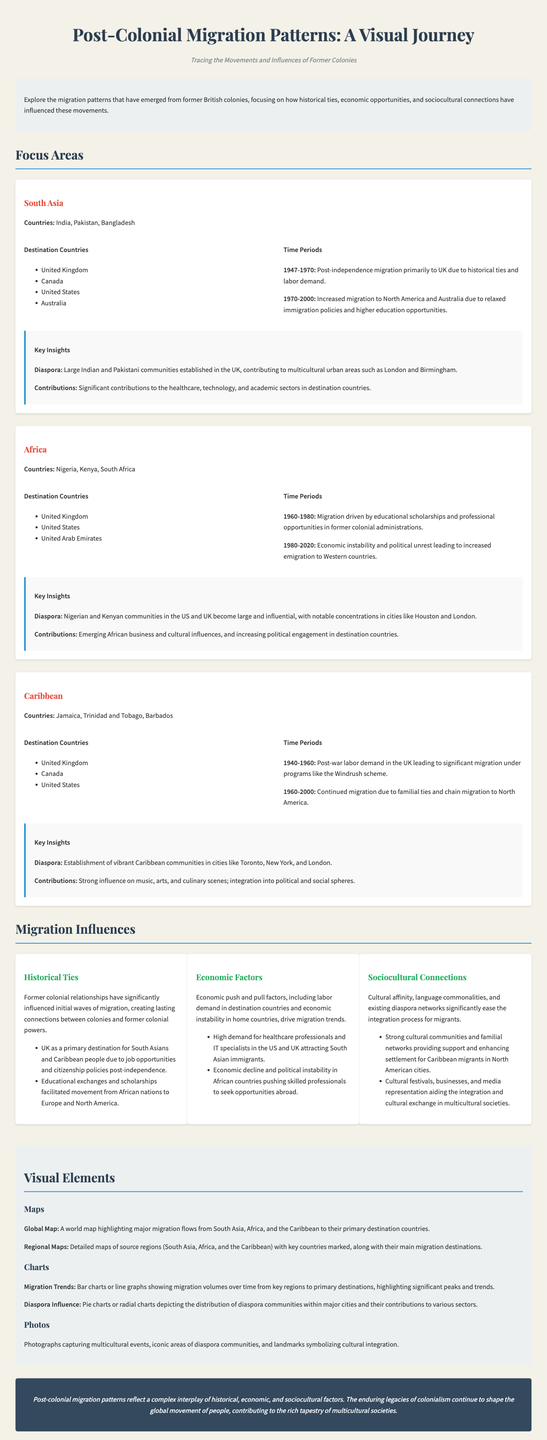what are the main countries in South Asia? The document lists India, Pakistan, and Bangladesh as the main countries in South Asia.
Answer: India, Pakistan, Bangladesh which time period saw migration from South Asia primarily to the UK? The infographic indicates that the time period from 1947 to 1970 saw post-independence migration mainly to the UK.
Answer: 1947-1970 what influences migration from African countries according to the document? Economic instability and political unrest are identified as key factors influencing migration from African countries.
Answer: Economic instability, political unrest which two regions have strong cultural communities supporting migratory integration? The document details strong cultural communities in the Caribbean and South Asia aiding in migration integration.
Answer: Caribbean, South Asia how many destination countries are listed for the Caribbean migration patterns? The document specifies three destination countries for Caribbean migration: the UK, Canada, and the US.
Answer: 3 what is a significant contribution of the Indian and Pakistani diaspora in the UK? According to the infographic, the Indian and Pakistani communities have made significant contributions to sectors such as healthcare, technology, and academia.
Answer: Healthcare, technology, academia what are the major destination countries for the Caribbean? The primary destination countries for people migrating from the Caribbean are listed as the UK, Canada, and the United States.
Answer: United Kingdom, Canada, United States which period saw increased migration from Africa due to educational opportunities? The document identifies the period from 1960 to 1980 as when migration from Africa was driven by educational scholarships.
Answer: 1960-1980 what type of visual elements are included in the infographic? The document mentions maps, charts, and photographs as types of visual elements included in the infographic.
Answer: Maps, charts, photographs 